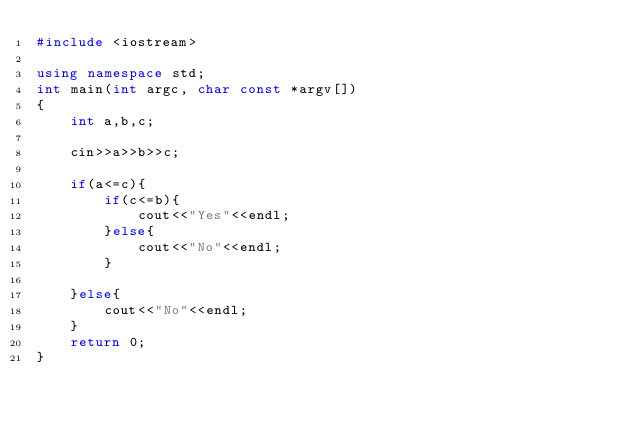Convert code to text. <code><loc_0><loc_0><loc_500><loc_500><_C++_>#include <iostream>

using namespace std;
int main(int argc, char const *argv[])
{
	int a,b,c;

	cin>>a>>b>>c;

	if(a<=c){
		if(c<=b){
			cout<<"Yes"<<endl;
		}else{
			cout<<"No"<<endl;
		}

	}else{
		cout<<"No"<<endl;
	}
	return 0;
}</code> 